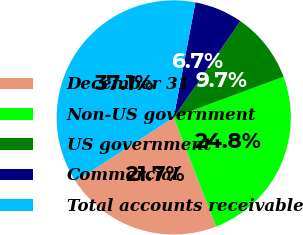Convert chart to OTSL. <chart><loc_0><loc_0><loc_500><loc_500><pie_chart><fcel>December 31<fcel>Non-US government<fcel>US government<fcel>Commercial<fcel>Total accounts receivable<nl><fcel>21.71%<fcel>24.76%<fcel>9.72%<fcel>6.67%<fcel>37.14%<nl></chart> 